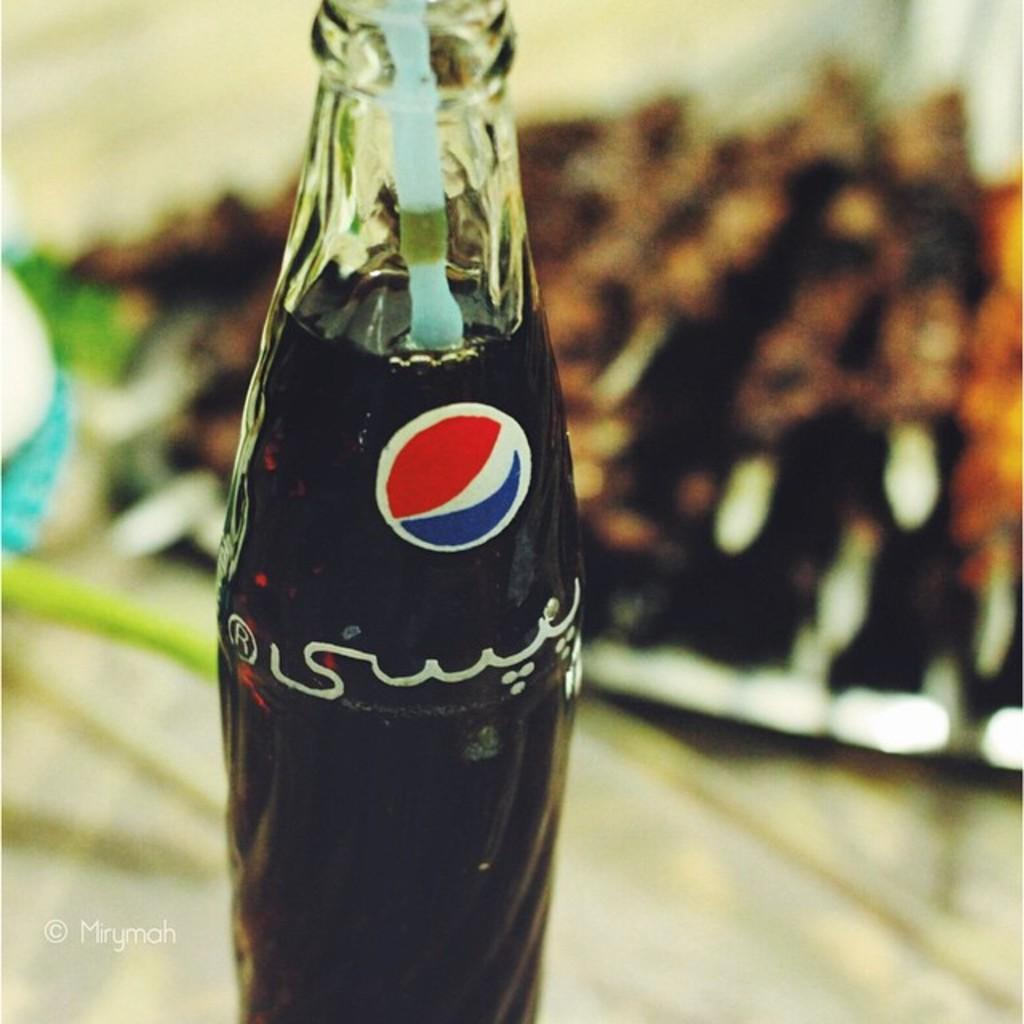What is contained within the bottle in the image? There is a full drink in the bottle in the image. What type of tail can be seen on the farmer in the image? There is no farmer or tail present in the image; it only features a bottle with a full drink. 